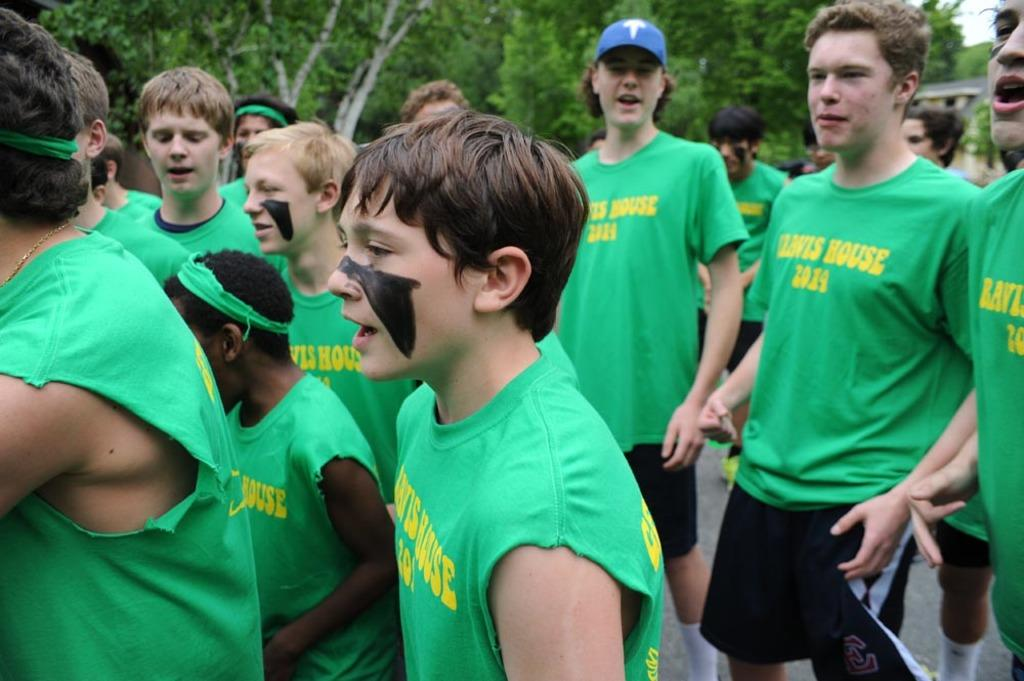How many people are present in the image? There are many people in the image. What can be seen in the background of the image? There are trees visible in the background of the image. What type of chalk is being used by the people in the image? There is no chalk present in the image, and therefore no such activity can be observed. How much money is being exchanged between the people in the image? There is no indication of any money exchange in the image. Is there any snow visible in the image? There is no snow present in the image. 